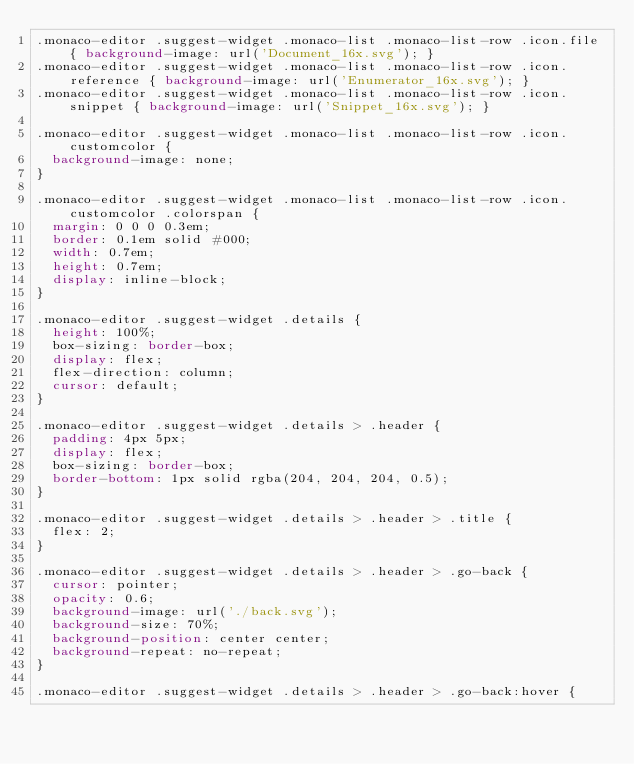Convert code to text. <code><loc_0><loc_0><loc_500><loc_500><_CSS_>.monaco-editor .suggest-widget .monaco-list .monaco-list-row .icon.file { background-image: url('Document_16x.svg'); }
.monaco-editor .suggest-widget .monaco-list .monaco-list-row .icon.reference { background-image: url('Enumerator_16x.svg'); }
.monaco-editor .suggest-widget .monaco-list .monaco-list-row .icon.snippet { background-image: url('Snippet_16x.svg'); }

.monaco-editor .suggest-widget .monaco-list .monaco-list-row .icon.customcolor {
	background-image: none;
}

.monaco-editor .suggest-widget .monaco-list .monaco-list-row .icon.customcolor .colorspan {
	margin: 0 0 0 0.3em;
	border: 0.1em solid #000;
	width: 0.7em;
	height: 0.7em;
	display: inline-block;
}

.monaco-editor .suggest-widget .details {
	height: 100%;
	box-sizing: border-box;
	display: flex;
	flex-direction: column;
	cursor: default;
}

.monaco-editor .suggest-widget .details > .header {
	padding: 4px 5px;
	display: flex;
	box-sizing: border-box;
	border-bottom: 1px solid rgba(204, 204, 204, 0.5);
}

.monaco-editor .suggest-widget .details > .header > .title {
	flex: 2;
}

.monaco-editor .suggest-widget .details > .header > .go-back {
	cursor: pointer;
	opacity: 0.6;
	background-image: url('./back.svg');
	background-size: 70%;
	background-position: center center;
	background-repeat: no-repeat;
}

.monaco-editor .suggest-widget .details > .header > .go-back:hover {</code> 